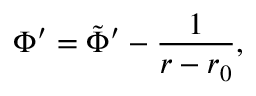<formula> <loc_0><loc_0><loc_500><loc_500>\Phi ^ { \prime } = \tilde { \Phi } ^ { \prime } - { \frac { 1 } { r - r _ { 0 } } } ,</formula> 